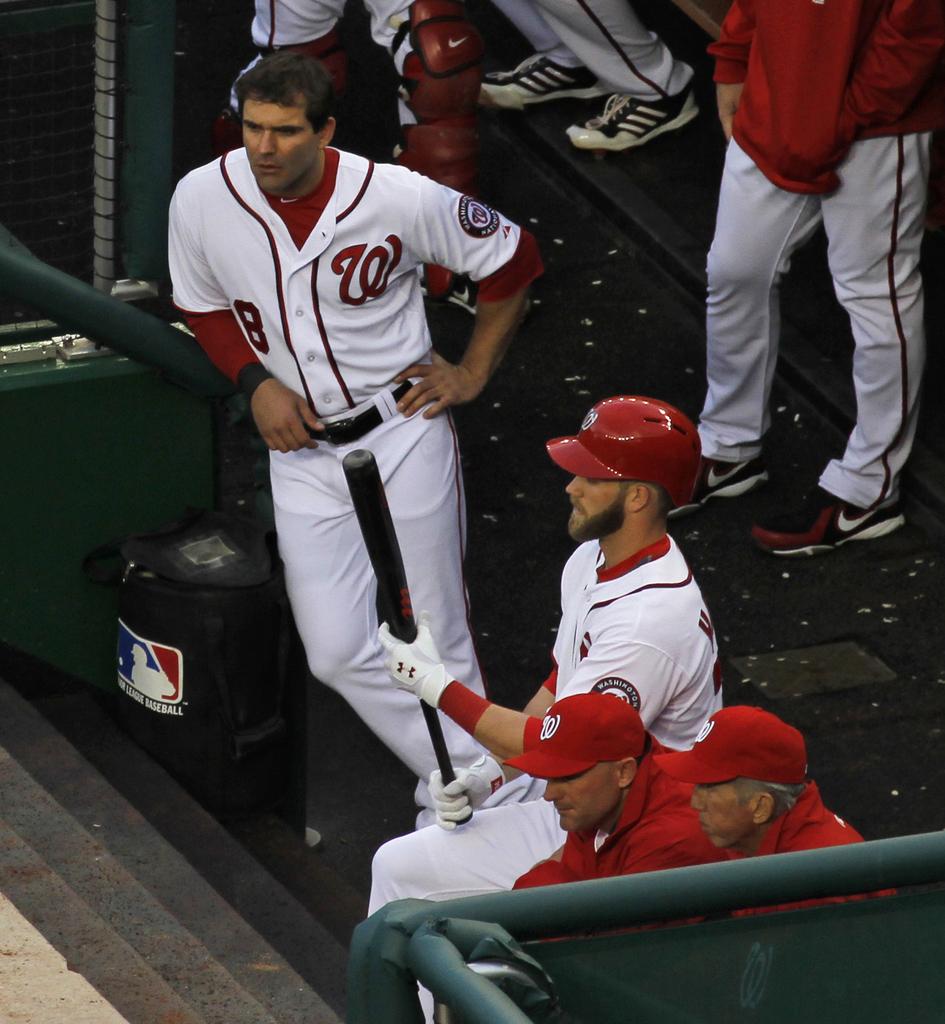What is the number of the standing player?
Ensure brevity in your answer.  8. 